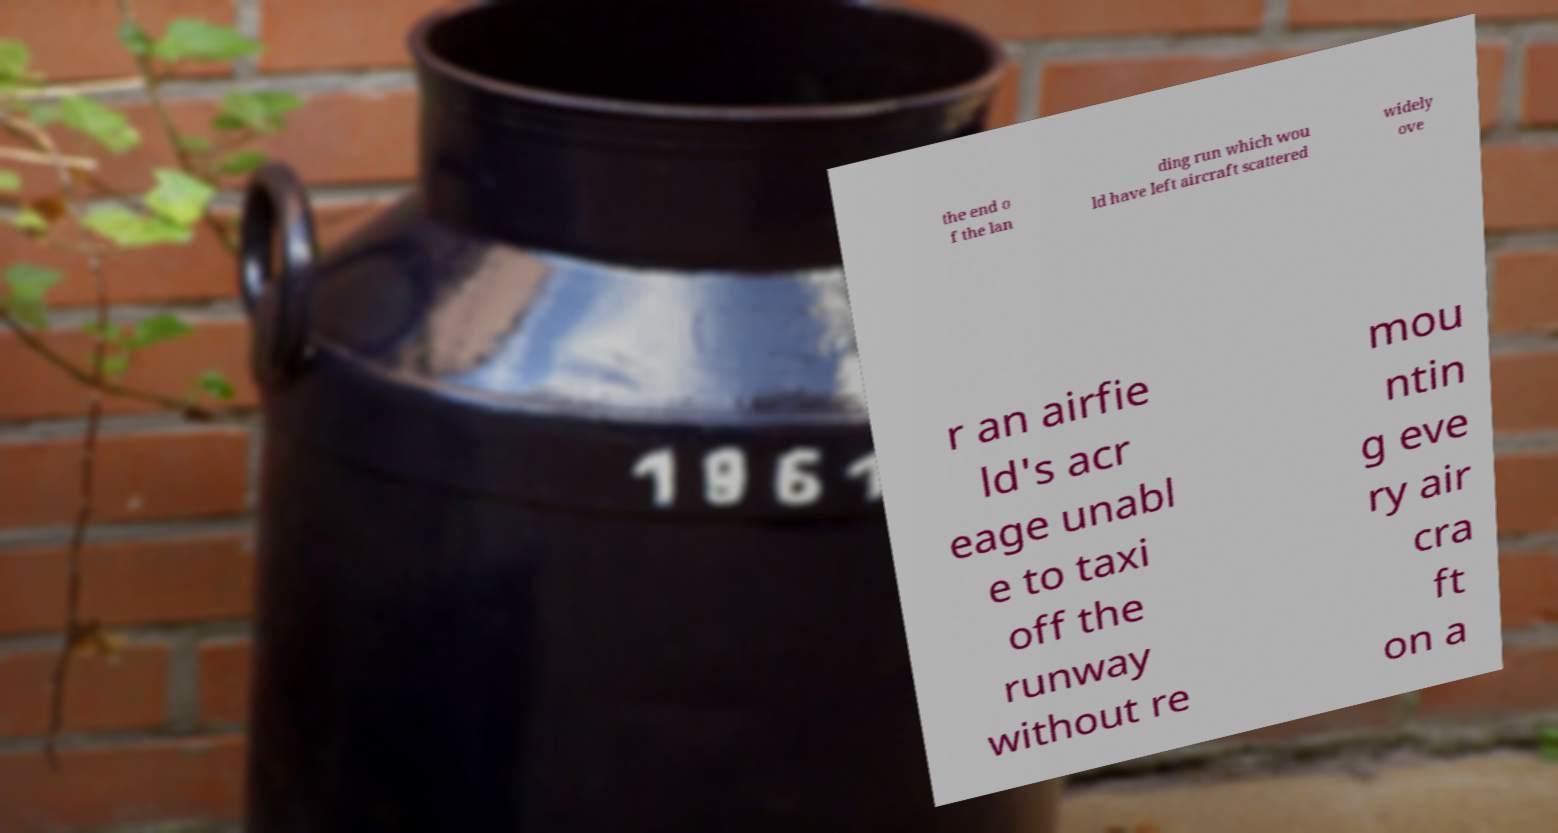Please identify and transcribe the text found in this image. the end o f the lan ding run which wou ld have left aircraft scattered widely ove r an airfie ld's acr eage unabl e to taxi off the runway without re mou ntin g eve ry air cra ft on a 